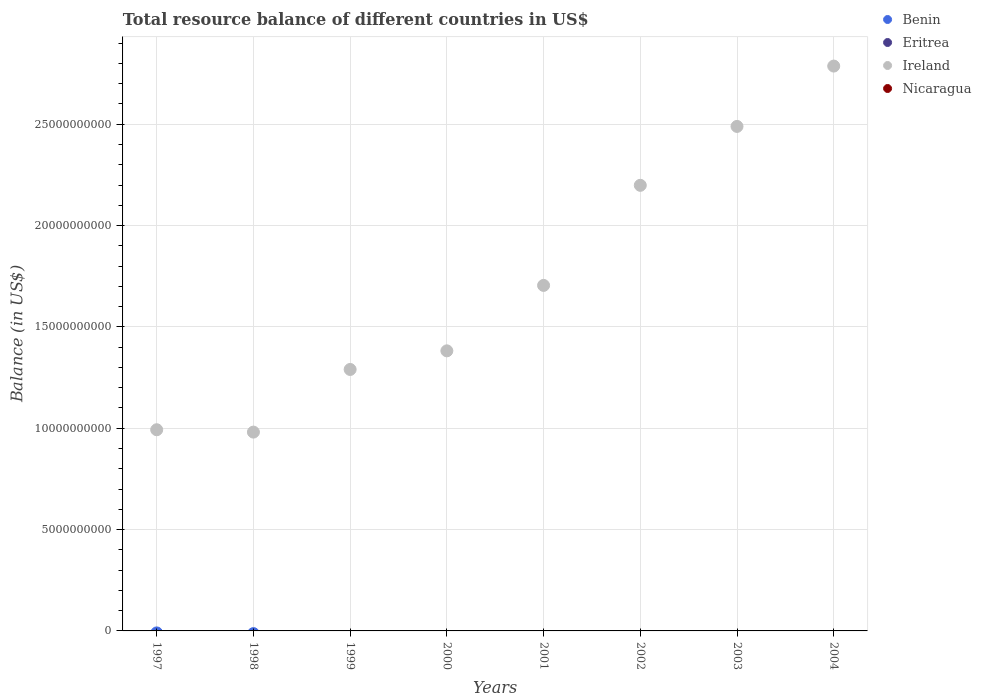How many different coloured dotlines are there?
Keep it short and to the point. 1. What is the total resource balance in Nicaragua in 1997?
Give a very brief answer. 0. Across all years, what is the minimum total resource balance in Nicaragua?
Your response must be concise. 0. What is the total total resource balance in Ireland in the graph?
Your response must be concise. 1.38e+11. What is the difference between the total resource balance in Benin in 2004 and the total resource balance in Ireland in 2000?
Your response must be concise. -1.38e+1. What is the average total resource balance in Ireland per year?
Make the answer very short. 1.73e+1. In how many years, is the total resource balance in Eritrea greater than 19000000000 US$?
Offer a very short reply. 0. What is the ratio of the total resource balance in Ireland in 2002 to that in 2004?
Ensure brevity in your answer.  0.79. What is the difference between the highest and the second highest total resource balance in Ireland?
Your answer should be very brief. 2.98e+09. What is the difference between the highest and the lowest total resource balance in Ireland?
Provide a short and direct response. 1.81e+1. In how many years, is the total resource balance in Nicaragua greater than the average total resource balance in Nicaragua taken over all years?
Offer a very short reply. 0. Is it the case that in every year, the sum of the total resource balance in Nicaragua and total resource balance in Ireland  is greater than the total resource balance in Eritrea?
Offer a very short reply. Yes. Does the total resource balance in Eritrea monotonically increase over the years?
Give a very brief answer. No. Is the total resource balance in Ireland strictly greater than the total resource balance in Nicaragua over the years?
Make the answer very short. Yes. How many years are there in the graph?
Offer a very short reply. 8. What is the difference between two consecutive major ticks on the Y-axis?
Give a very brief answer. 5.00e+09. Are the values on the major ticks of Y-axis written in scientific E-notation?
Provide a succinct answer. No. Does the graph contain any zero values?
Your answer should be compact. Yes. Where does the legend appear in the graph?
Your answer should be compact. Top right. What is the title of the graph?
Give a very brief answer. Total resource balance of different countries in US$. Does "Virgin Islands" appear as one of the legend labels in the graph?
Offer a terse response. No. What is the label or title of the X-axis?
Keep it short and to the point. Years. What is the label or title of the Y-axis?
Your response must be concise. Balance (in US$). What is the Balance (in US$) in Ireland in 1997?
Keep it short and to the point. 9.93e+09. What is the Balance (in US$) of Nicaragua in 1997?
Your response must be concise. 0. What is the Balance (in US$) in Benin in 1998?
Make the answer very short. 0. What is the Balance (in US$) of Ireland in 1998?
Provide a short and direct response. 9.81e+09. What is the Balance (in US$) in Nicaragua in 1998?
Offer a very short reply. 0. What is the Balance (in US$) in Ireland in 1999?
Your response must be concise. 1.29e+1. What is the Balance (in US$) of Eritrea in 2000?
Provide a succinct answer. 0. What is the Balance (in US$) in Ireland in 2000?
Offer a terse response. 1.38e+1. What is the Balance (in US$) of Nicaragua in 2000?
Make the answer very short. 0. What is the Balance (in US$) in Benin in 2001?
Keep it short and to the point. 0. What is the Balance (in US$) of Ireland in 2001?
Ensure brevity in your answer.  1.70e+1. What is the Balance (in US$) of Eritrea in 2002?
Offer a very short reply. 0. What is the Balance (in US$) of Ireland in 2002?
Provide a short and direct response. 2.20e+1. What is the Balance (in US$) of Nicaragua in 2002?
Your answer should be very brief. 0. What is the Balance (in US$) of Benin in 2003?
Offer a terse response. 0. What is the Balance (in US$) of Eritrea in 2003?
Your answer should be very brief. 0. What is the Balance (in US$) in Ireland in 2003?
Offer a terse response. 2.49e+1. What is the Balance (in US$) in Nicaragua in 2003?
Ensure brevity in your answer.  0. What is the Balance (in US$) in Ireland in 2004?
Offer a very short reply. 2.79e+1. What is the Balance (in US$) of Nicaragua in 2004?
Your response must be concise. 0. Across all years, what is the maximum Balance (in US$) of Ireland?
Ensure brevity in your answer.  2.79e+1. Across all years, what is the minimum Balance (in US$) of Ireland?
Your answer should be very brief. 9.81e+09. What is the total Balance (in US$) of Eritrea in the graph?
Ensure brevity in your answer.  0. What is the total Balance (in US$) in Ireland in the graph?
Provide a short and direct response. 1.38e+11. What is the total Balance (in US$) of Nicaragua in the graph?
Your response must be concise. 0. What is the difference between the Balance (in US$) of Ireland in 1997 and that in 1998?
Provide a succinct answer. 1.16e+08. What is the difference between the Balance (in US$) of Ireland in 1997 and that in 1999?
Give a very brief answer. -2.97e+09. What is the difference between the Balance (in US$) of Ireland in 1997 and that in 2000?
Provide a succinct answer. -3.89e+09. What is the difference between the Balance (in US$) in Ireland in 1997 and that in 2001?
Offer a terse response. -7.12e+09. What is the difference between the Balance (in US$) of Ireland in 1997 and that in 2002?
Ensure brevity in your answer.  -1.21e+1. What is the difference between the Balance (in US$) in Ireland in 1997 and that in 2003?
Ensure brevity in your answer.  -1.50e+1. What is the difference between the Balance (in US$) in Ireland in 1997 and that in 2004?
Your answer should be very brief. -1.79e+1. What is the difference between the Balance (in US$) of Ireland in 1998 and that in 1999?
Your answer should be compact. -3.09e+09. What is the difference between the Balance (in US$) of Ireland in 1998 and that in 2000?
Make the answer very short. -4.01e+09. What is the difference between the Balance (in US$) in Ireland in 1998 and that in 2001?
Offer a terse response. -7.24e+09. What is the difference between the Balance (in US$) in Ireland in 1998 and that in 2002?
Your response must be concise. -1.22e+1. What is the difference between the Balance (in US$) of Ireland in 1998 and that in 2003?
Offer a terse response. -1.51e+1. What is the difference between the Balance (in US$) in Ireland in 1998 and that in 2004?
Make the answer very short. -1.81e+1. What is the difference between the Balance (in US$) of Ireland in 1999 and that in 2000?
Your response must be concise. -9.19e+08. What is the difference between the Balance (in US$) in Ireland in 1999 and that in 2001?
Your answer should be compact. -4.15e+09. What is the difference between the Balance (in US$) of Ireland in 1999 and that in 2002?
Your response must be concise. -9.09e+09. What is the difference between the Balance (in US$) in Ireland in 1999 and that in 2003?
Your answer should be compact. -1.20e+1. What is the difference between the Balance (in US$) in Ireland in 1999 and that in 2004?
Give a very brief answer. -1.50e+1. What is the difference between the Balance (in US$) of Ireland in 2000 and that in 2001?
Make the answer very short. -3.23e+09. What is the difference between the Balance (in US$) of Ireland in 2000 and that in 2002?
Ensure brevity in your answer.  -8.17e+09. What is the difference between the Balance (in US$) in Ireland in 2000 and that in 2003?
Ensure brevity in your answer.  -1.11e+1. What is the difference between the Balance (in US$) of Ireland in 2000 and that in 2004?
Provide a short and direct response. -1.41e+1. What is the difference between the Balance (in US$) in Ireland in 2001 and that in 2002?
Your answer should be very brief. -4.94e+09. What is the difference between the Balance (in US$) of Ireland in 2001 and that in 2003?
Your response must be concise. -7.84e+09. What is the difference between the Balance (in US$) of Ireland in 2001 and that in 2004?
Your response must be concise. -1.08e+1. What is the difference between the Balance (in US$) of Ireland in 2002 and that in 2003?
Your answer should be compact. -2.91e+09. What is the difference between the Balance (in US$) in Ireland in 2002 and that in 2004?
Make the answer very short. -5.88e+09. What is the difference between the Balance (in US$) in Ireland in 2003 and that in 2004?
Make the answer very short. -2.98e+09. What is the average Balance (in US$) in Ireland per year?
Offer a very short reply. 1.73e+1. What is the ratio of the Balance (in US$) in Ireland in 1997 to that in 1998?
Provide a succinct answer. 1.01. What is the ratio of the Balance (in US$) in Ireland in 1997 to that in 1999?
Offer a very short reply. 0.77. What is the ratio of the Balance (in US$) in Ireland in 1997 to that in 2000?
Give a very brief answer. 0.72. What is the ratio of the Balance (in US$) of Ireland in 1997 to that in 2001?
Ensure brevity in your answer.  0.58. What is the ratio of the Balance (in US$) of Ireland in 1997 to that in 2002?
Make the answer very short. 0.45. What is the ratio of the Balance (in US$) in Ireland in 1997 to that in 2003?
Provide a short and direct response. 0.4. What is the ratio of the Balance (in US$) of Ireland in 1997 to that in 2004?
Make the answer very short. 0.36. What is the ratio of the Balance (in US$) of Ireland in 1998 to that in 1999?
Ensure brevity in your answer.  0.76. What is the ratio of the Balance (in US$) in Ireland in 1998 to that in 2000?
Provide a short and direct response. 0.71. What is the ratio of the Balance (in US$) of Ireland in 1998 to that in 2001?
Your answer should be very brief. 0.58. What is the ratio of the Balance (in US$) in Ireland in 1998 to that in 2002?
Offer a very short reply. 0.45. What is the ratio of the Balance (in US$) of Ireland in 1998 to that in 2003?
Make the answer very short. 0.39. What is the ratio of the Balance (in US$) of Ireland in 1998 to that in 2004?
Offer a very short reply. 0.35. What is the ratio of the Balance (in US$) in Ireland in 1999 to that in 2000?
Your answer should be very brief. 0.93. What is the ratio of the Balance (in US$) in Ireland in 1999 to that in 2001?
Ensure brevity in your answer.  0.76. What is the ratio of the Balance (in US$) in Ireland in 1999 to that in 2002?
Ensure brevity in your answer.  0.59. What is the ratio of the Balance (in US$) in Ireland in 1999 to that in 2003?
Offer a terse response. 0.52. What is the ratio of the Balance (in US$) of Ireland in 1999 to that in 2004?
Provide a succinct answer. 0.46. What is the ratio of the Balance (in US$) of Ireland in 2000 to that in 2001?
Ensure brevity in your answer.  0.81. What is the ratio of the Balance (in US$) in Ireland in 2000 to that in 2002?
Keep it short and to the point. 0.63. What is the ratio of the Balance (in US$) of Ireland in 2000 to that in 2003?
Provide a short and direct response. 0.56. What is the ratio of the Balance (in US$) of Ireland in 2000 to that in 2004?
Your answer should be compact. 0.5. What is the ratio of the Balance (in US$) of Ireland in 2001 to that in 2002?
Provide a succinct answer. 0.78. What is the ratio of the Balance (in US$) of Ireland in 2001 to that in 2003?
Make the answer very short. 0.68. What is the ratio of the Balance (in US$) of Ireland in 2001 to that in 2004?
Make the answer very short. 0.61. What is the ratio of the Balance (in US$) in Ireland in 2002 to that in 2003?
Ensure brevity in your answer.  0.88. What is the ratio of the Balance (in US$) of Ireland in 2002 to that in 2004?
Offer a terse response. 0.79. What is the ratio of the Balance (in US$) in Ireland in 2003 to that in 2004?
Your answer should be compact. 0.89. What is the difference between the highest and the second highest Balance (in US$) in Ireland?
Your answer should be compact. 2.98e+09. What is the difference between the highest and the lowest Balance (in US$) in Ireland?
Provide a succinct answer. 1.81e+1. 